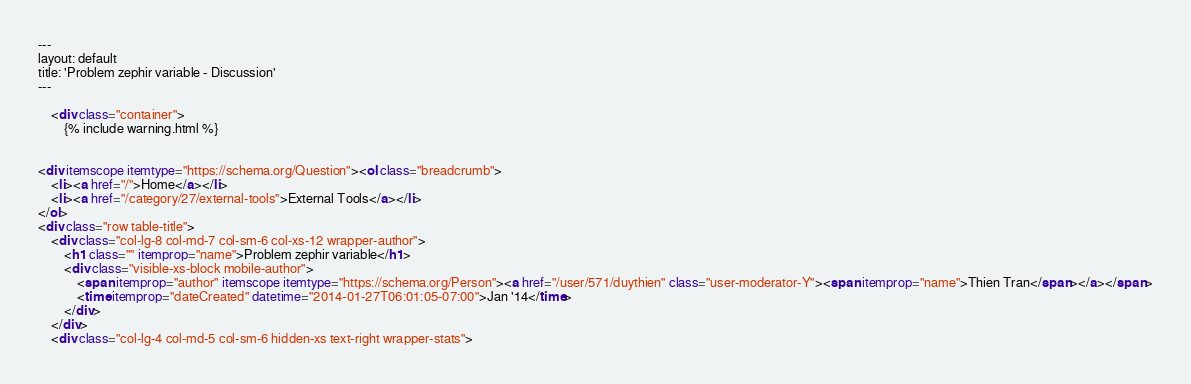Convert code to text. <code><loc_0><loc_0><loc_500><loc_500><_HTML_>---
layout: default
title: 'Problem zephir variable - Discussion'
---

    <div class="container">
        {% include warning.html %}


<div itemscope itemtype="https://schema.org/Question"><ol class="breadcrumb">
    <li><a href="/">Home</a></li>
    <li><a href="/category/27/external-tools">External Tools</a></li>
</ol>
<div class="row table-title">
    <div class="col-lg-8 col-md-7 col-sm-6 col-xs-12 wrapper-author">
        <h1 class="" itemprop="name">Problem zephir variable</h1>
        <div class="visible-xs-block mobile-author">
            <span itemprop="author" itemscope itemtype="https://schema.org/Person"><a href="/user/571/duythien" class="user-moderator-Y"><span itemprop="name">Thien Tran</span></a></span>
            <time itemprop="dateCreated" datetime="2014-01-27T06:01:05-07:00">Jan '14</time>
        </div>
    </div>
    <div class="col-lg-4 col-md-5 col-sm-6 hidden-xs text-right wrapper-stats"></code> 